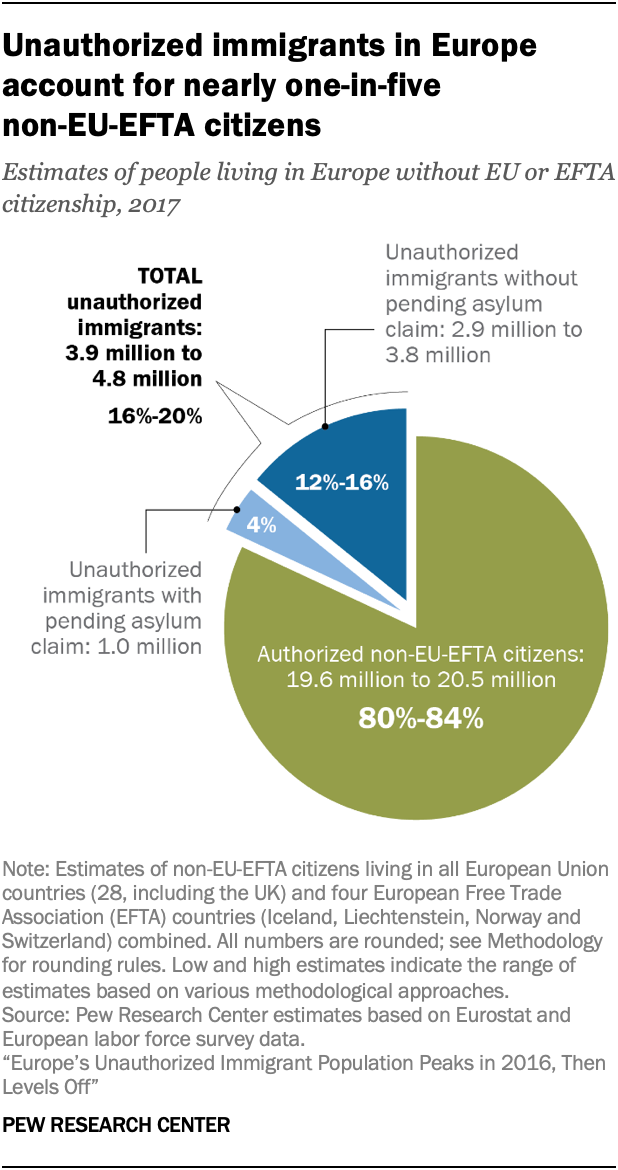Indicate a few pertinent items in this graphic. The largest pie is green in color. According to recent estimates, approximately 80-84% of authorized non-EU EFTA citizens are currently living in Europe. 